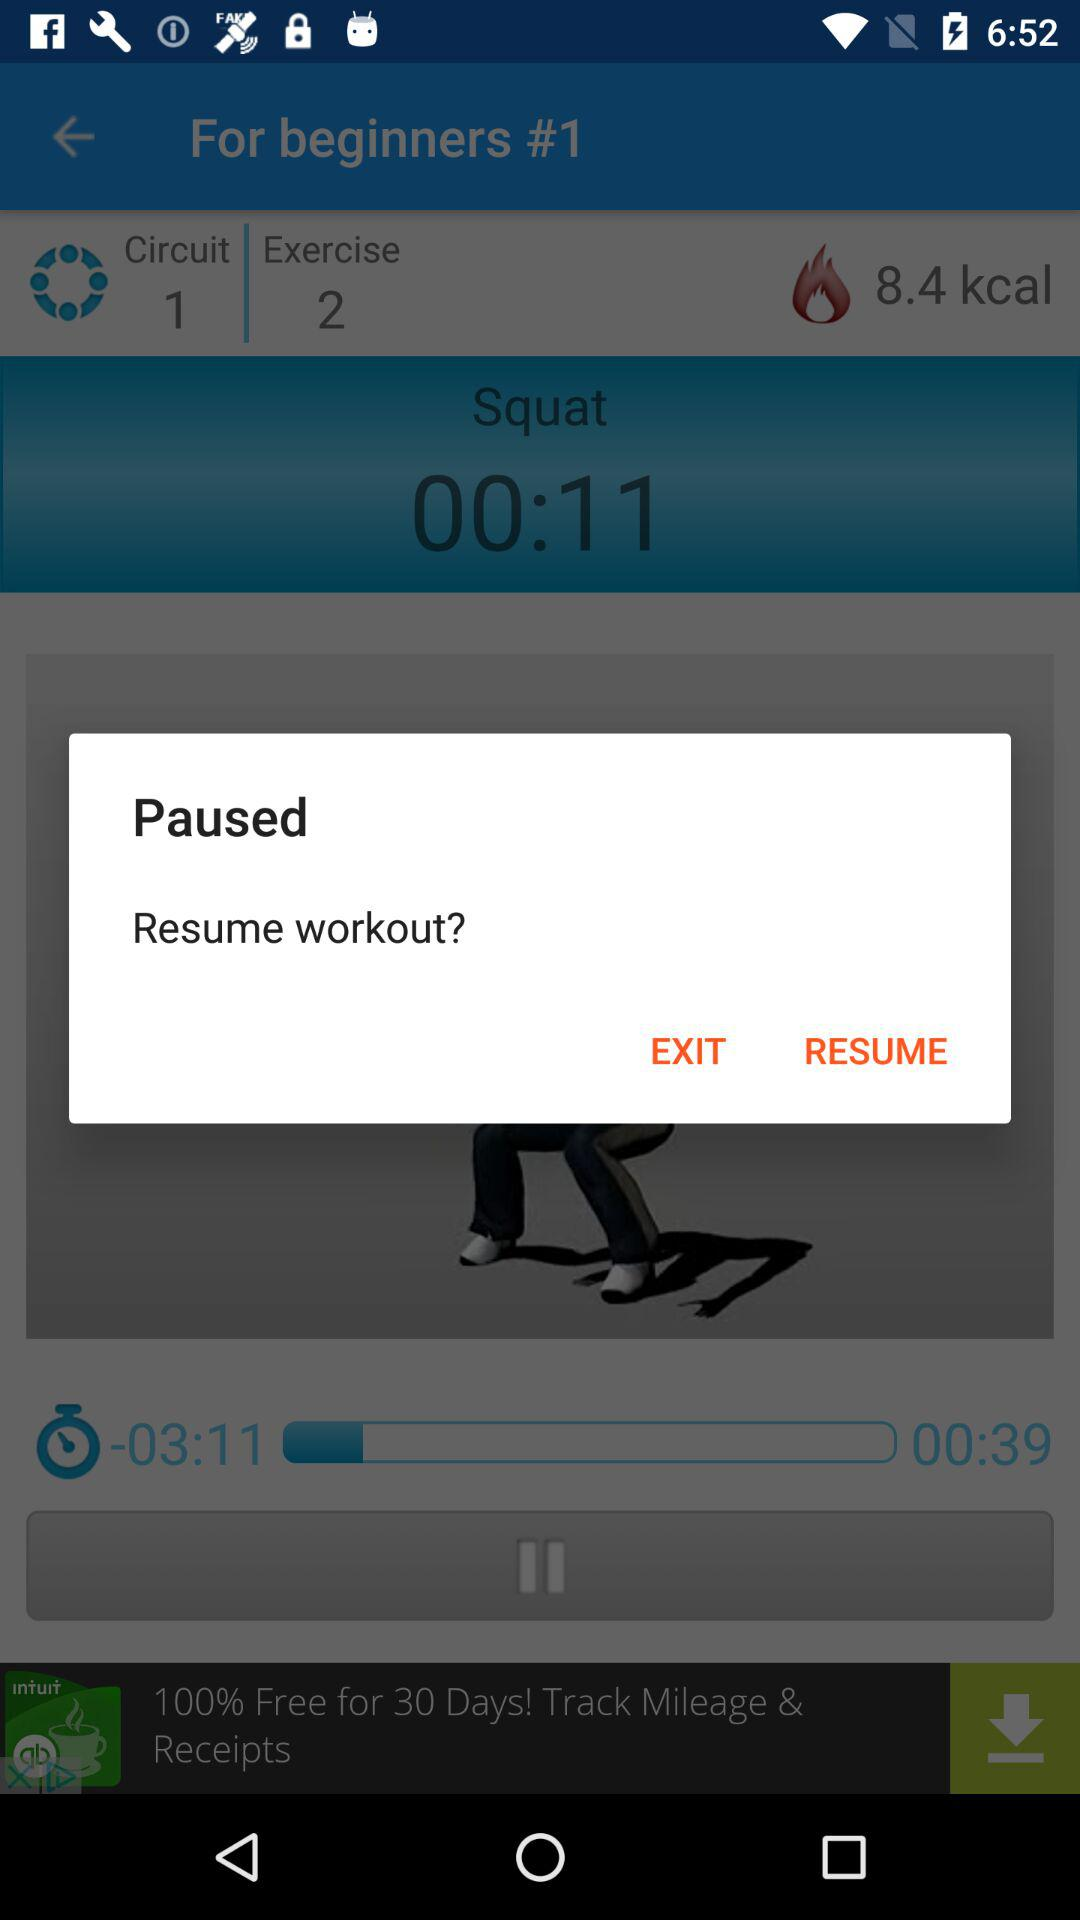What is the tagline of S Health? The tagline is "Get Fit, Stay Fit". 